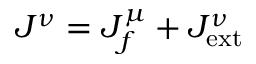<formula> <loc_0><loc_0><loc_500><loc_500>J ^ { \nu } = J _ { f } ^ { \mu } + J _ { e x t } ^ { \nu }</formula> 